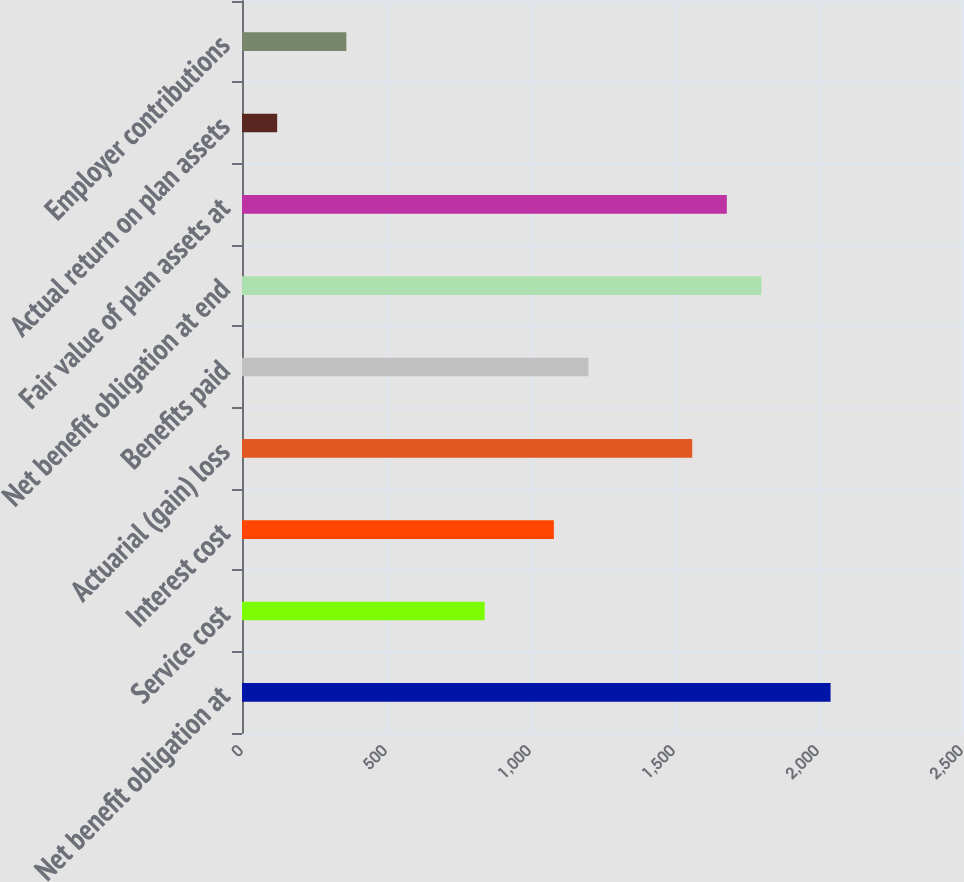Convert chart to OTSL. <chart><loc_0><loc_0><loc_500><loc_500><bar_chart><fcel>Net benefit obligation at<fcel>Service cost<fcel>Interest cost<fcel>Actuarial (gain) loss<fcel>Benefits paid<fcel>Net benefit obligation at end<fcel>Fair value of plan assets at<fcel>Actual return on plan assets<fcel>Employer contributions<nl><fcel>2043.7<fcel>842.7<fcel>1082.9<fcel>1563.3<fcel>1203<fcel>1803.5<fcel>1683.4<fcel>122.1<fcel>362.3<nl></chart> 